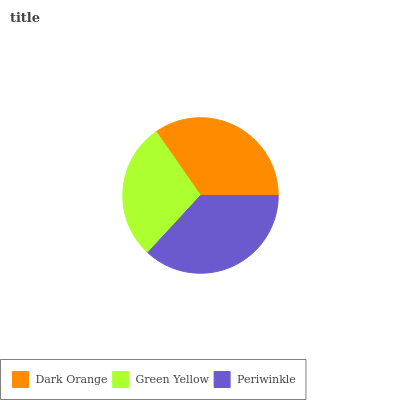Is Green Yellow the minimum?
Answer yes or no. Yes. Is Periwinkle the maximum?
Answer yes or no. Yes. Is Periwinkle the minimum?
Answer yes or no. No. Is Green Yellow the maximum?
Answer yes or no. No. Is Periwinkle greater than Green Yellow?
Answer yes or no. Yes. Is Green Yellow less than Periwinkle?
Answer yes or no. Yes. Is Green Yellow greater than Periwinkle?
Answer yes or no. No. Is Periwinkle less than Green Yellow?
Answer yes or no. No. Is Dark Orange the high median?
Answer yes or no. Yes. Is Dark Orange the low median?
Answer yes or no. Yes. Is Green Yellow the high median?
Answer yes or no. No. Is Green Yellow the low median?
Answer yes or no. No. 